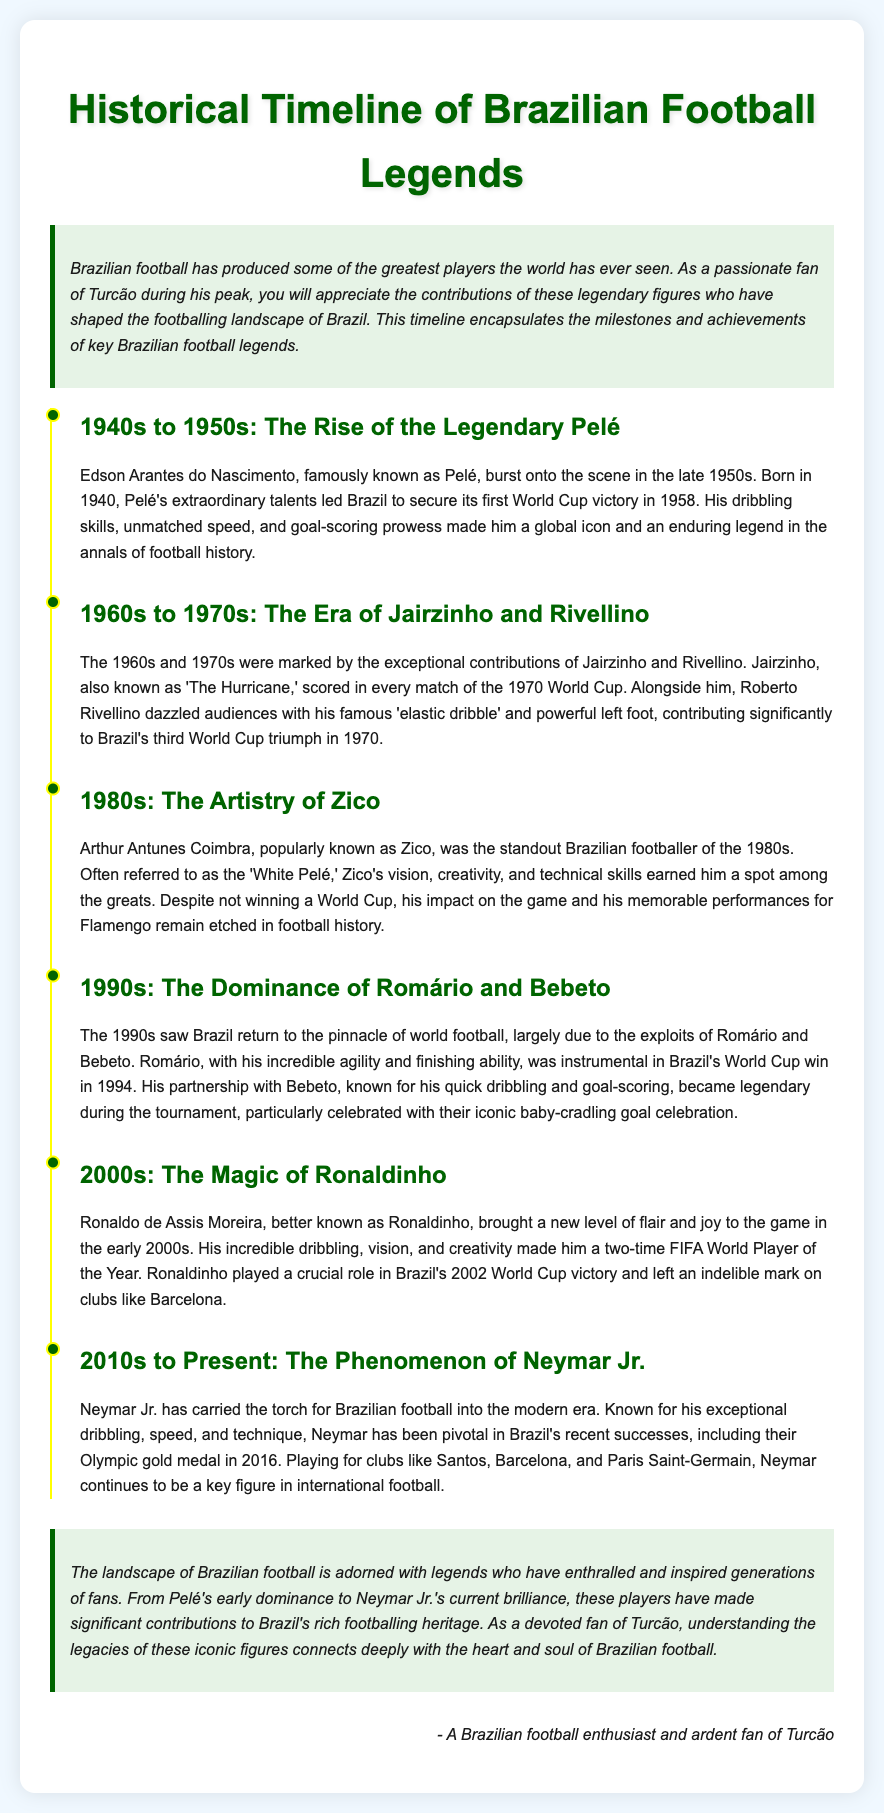What is the birth year of Pelé? Pelé was born in the year 1940
Answer: 1940 Which World Cup did Pelé help Brazil win? The document states that Pelé helped Brazil secure its first World Cup victory in 1958
Answer: 1958 Who scored in every match of the 1970 World Cup? Jairzinho, referred to as 'The Hurricane,' scored in every match of the 1970 World Cup
Answer: Jairzinho What is Zico commonly referred to as? Zico is often referred to as the 'White Pelé'
Answer: White Pelé In which decade did Romário and Bebeto dominate Brazilian football? The 1990s saw the dominance of Romário and Bebeto
Answer: 1990s What important contribution did Ronaldinho make in 2002? Ronaldinho played a crucial role in Brazil's 2002 World Cup victory
Answer: 2002 World Cup victory How many FIFA World Player of the Year awards did Ronaldinho win? Ronaldinho was a two-time FIFA World Player of the Year
Answer: Two What significant medal did Neymar Jr. help Brazil achieve in 2016? Neymar Jr. was pivotal in Brazil's Olympic gold medal in 2016
Answer: Olympic gold medal 